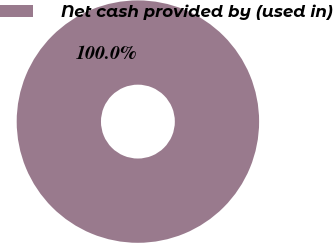<chart> <loc_0><loc_0><loc_500><loc_500><pie_chart><fcel>Net cash provided by (used in)<nl><fcel>100.0%<nl></chart> 